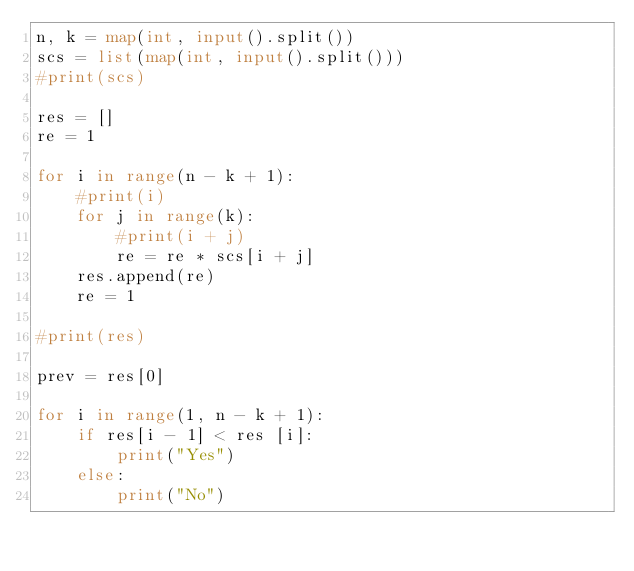<code> <loc_0><loc_0><loc_500><loc_500><_Python_>n, k = map(int, input().split())
scs = list(map(int, input().split()))
#print(scs)

res = []
re = 1

for i in range(n - k + 1):
    #print(i)
    for j in range(k):
        #print(i + j)
        re = re * scs[i + j]
    res.append(re)
    re = 1

#print(res)

prev = res[0]

for i in range(1, n - k + 1):
    if res[i - 1] < res [i]:
        print("Yes")
    else:
        print("No")
</code> 